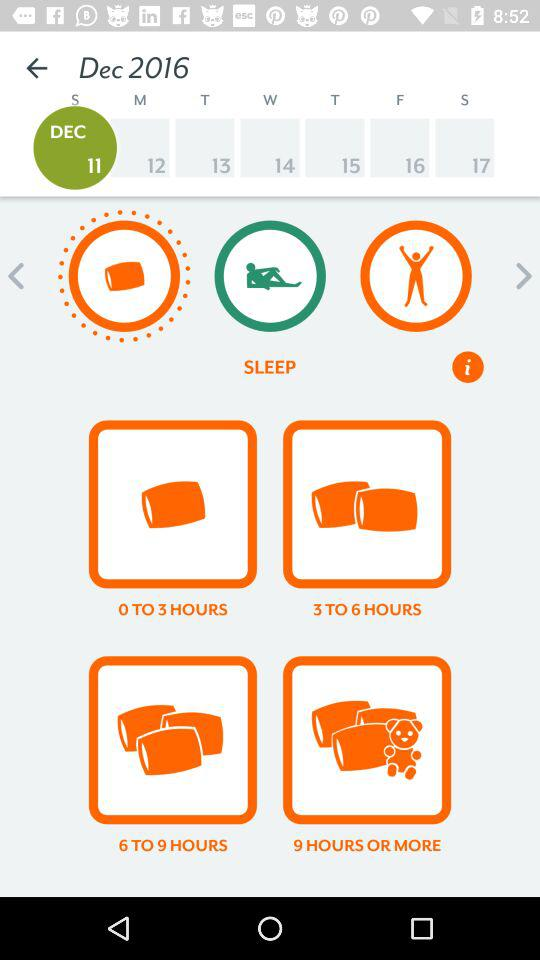What date is selected on the screen? The selected date is Sunday, December 11, 2016. 